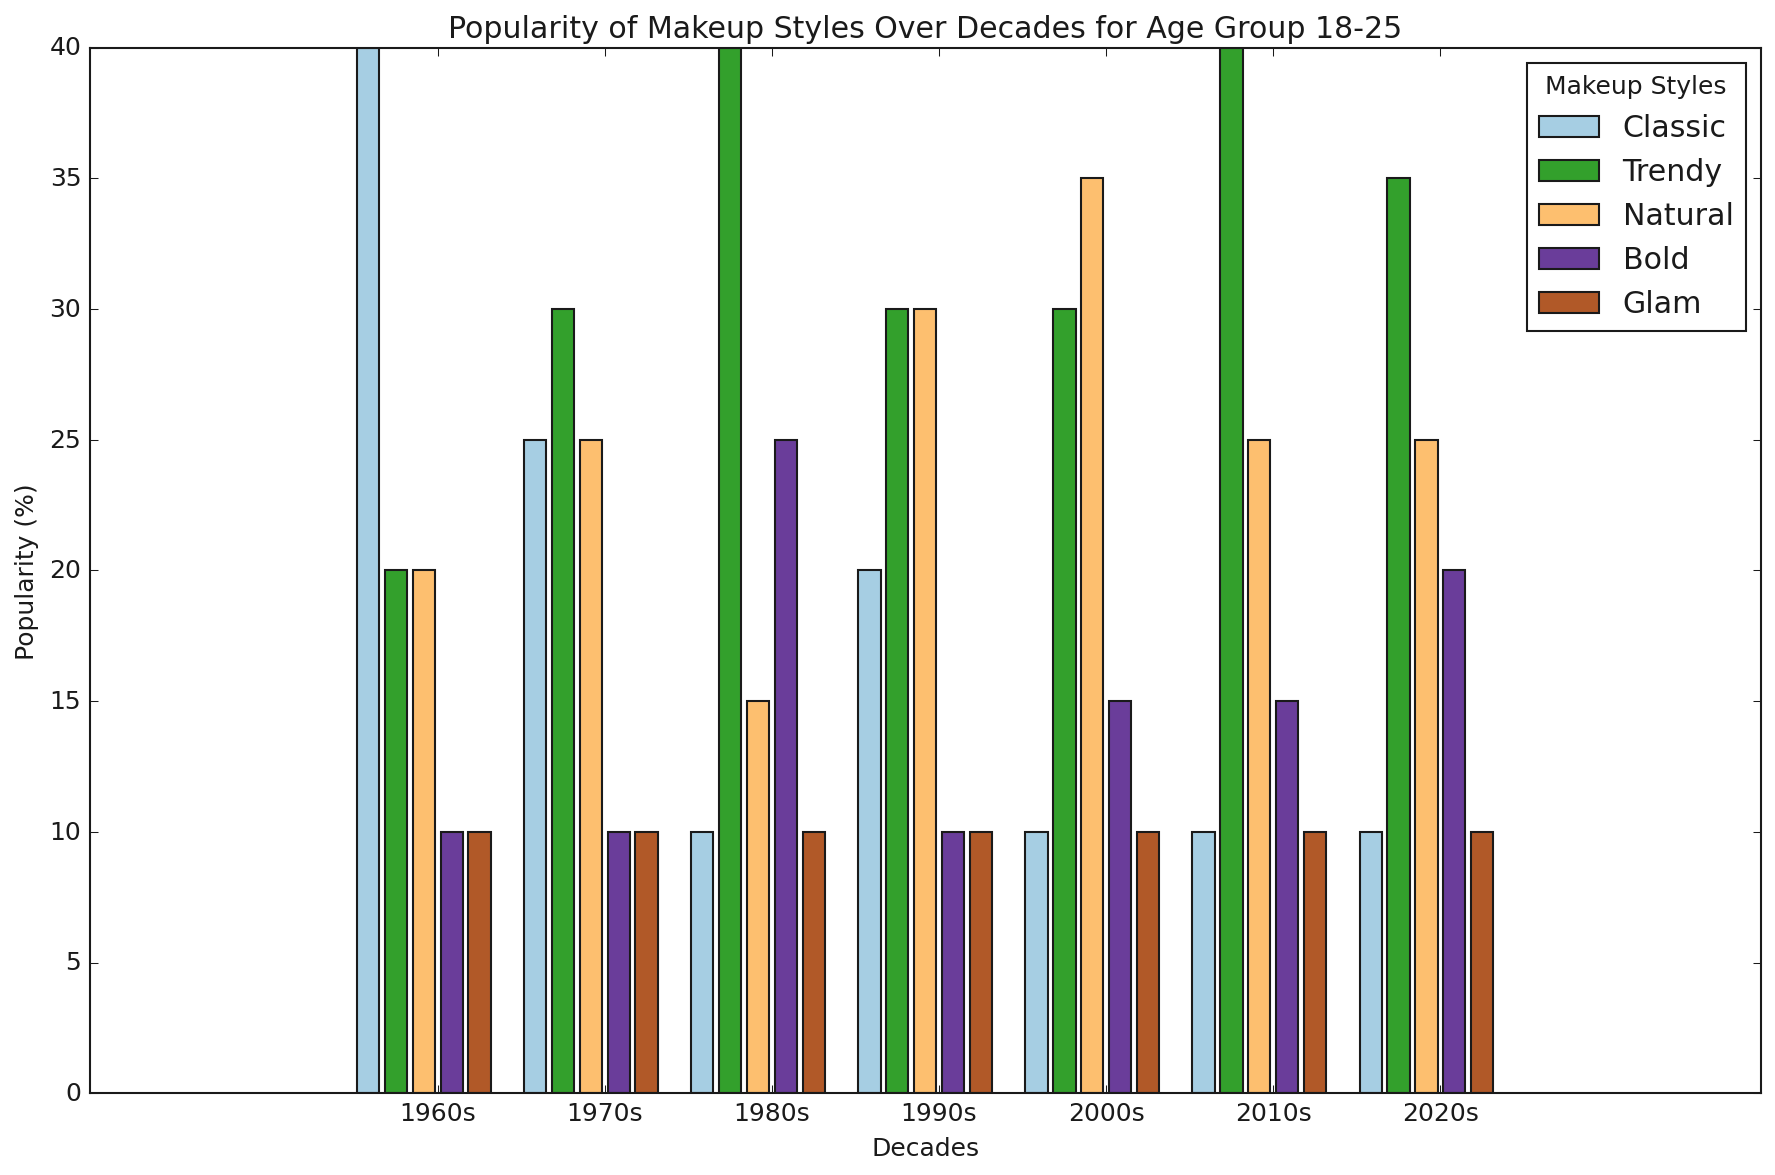What decade shows the highest popularity of the 'Bold' makeup style for the age group 18-25? To determine this, look for the tallest bar in the 'Bold' category for the age group 18-25 across all decades. In the figure, the 'Bold' bars are color-coded. The tallest bar is in the 1980s, indicating the highest popularity of the 'Bold' style during that decade for the age group 18-25.
Answer: 1980s In the 1970s, which makeup style was more popular among the 18-25 age group, 'Classic' or 'Trendy'? Compare the height of the 'Classic' and 'Trendy' bars for the 18-25 age group in the 1970s. The height of the 'Trendy' bar is higher than the 'Classic' bar, meaning 'Trendy' was more popular among this age group.
Answer: Trendy What makeup style shows a consistent increase in popularity from the 1960s to the 2020s for the age group 18-25? Analyze the heights of each bar across the decades for the age group 18-25. Look for a style where the bar's height consistently increases. None of the styles shows a consistent increase over all these decades when only considering the '18-25' age group.
Answer: None Which age group in the 1960s had the highest popularity for the 'Natural' makeup style? Examine the 'Natural' bars within the 1960s for all age groups. The '56+' age group shows the highest bar for the 'Natural' makeup style.
Answer: 56+ During which decade did the 'Glam' makeup style gain the most popularity for the 18-25 age group? Find the decade where the 'Glam' bar is the tallest for the 18-25 age group. Bars reflecting the 'Glam' style show the same height across all decades, indicating no single decade where 'Glam' gained more popularity within the age group.
Answer: Consistently low 